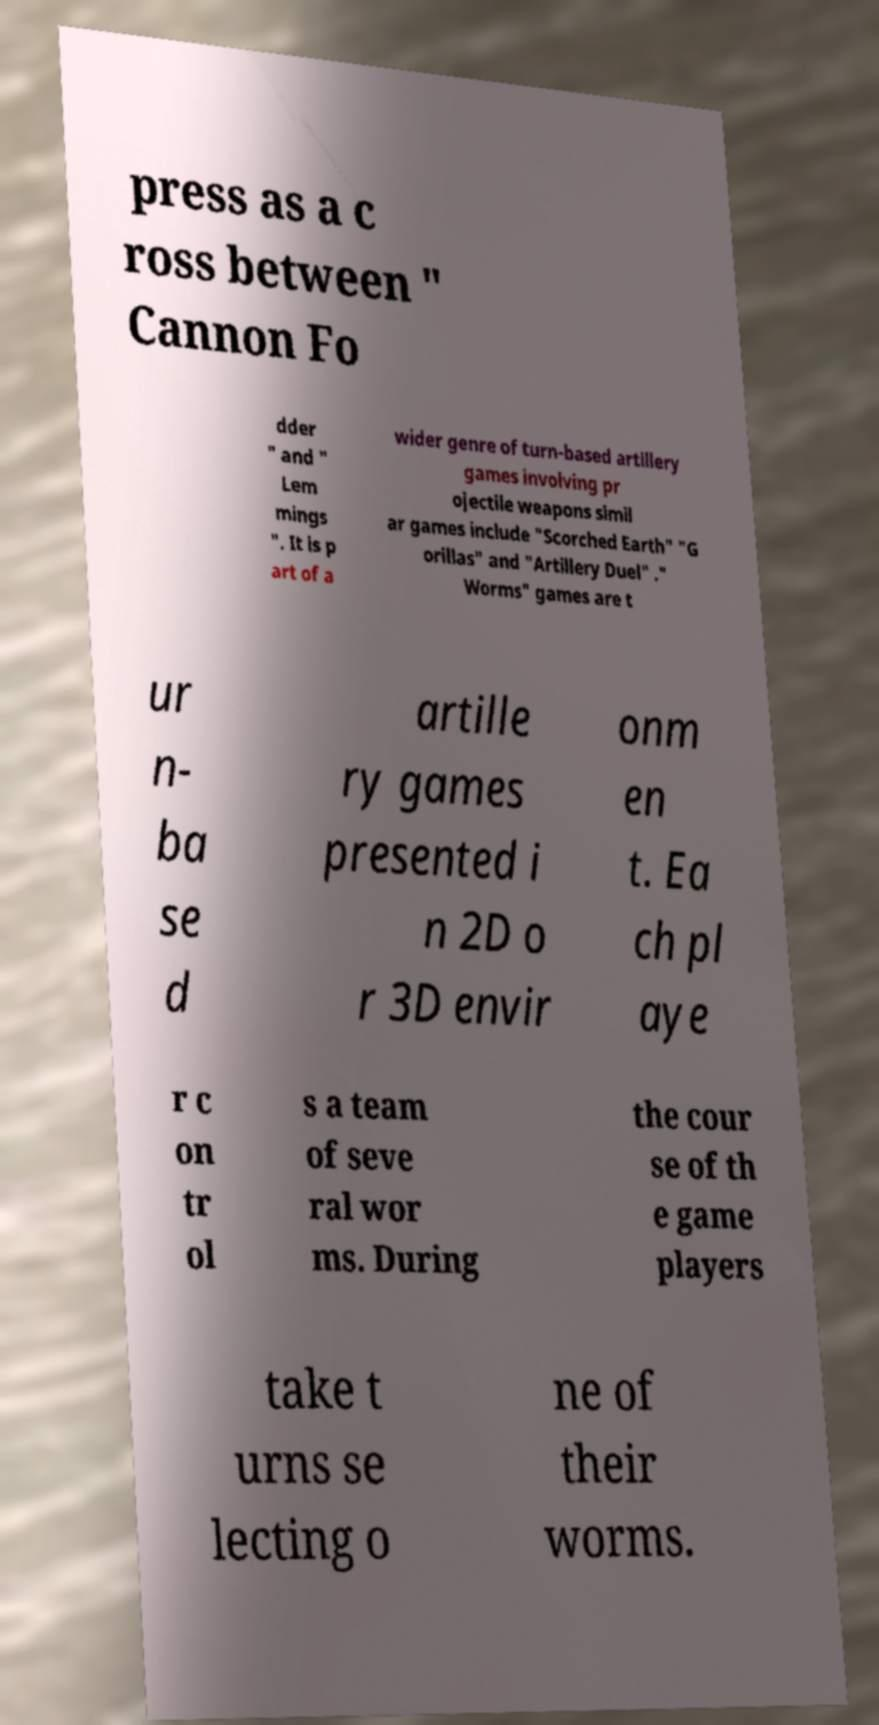For documentation purposes, I need the text within this image transcribed. Could you provide that? press as a c ross between " Cannon Fo dder " and " Lem mings ". It is p art of a wider genre of turn-based artillery games involving pr ojectile weapons simil ar games include "Scorched Earth" "G orillas" and "Artillery Duel" ." Worms" games are t ur n- ba se d artille ry games presented i n 2D o r 3D envir onm en t. Ea ch pl aye r c on tr ol s a team of seve ral wor ms. During the cour se of th e game players take t urns se lecting o ne of their worms. 